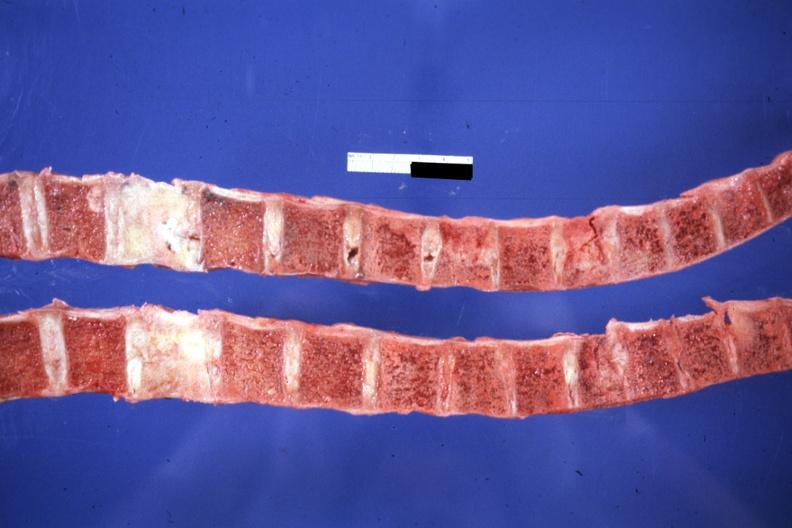do saggital section typical not know history but probably breast lesion?
Answer the question using a single word or phrase. Yes 